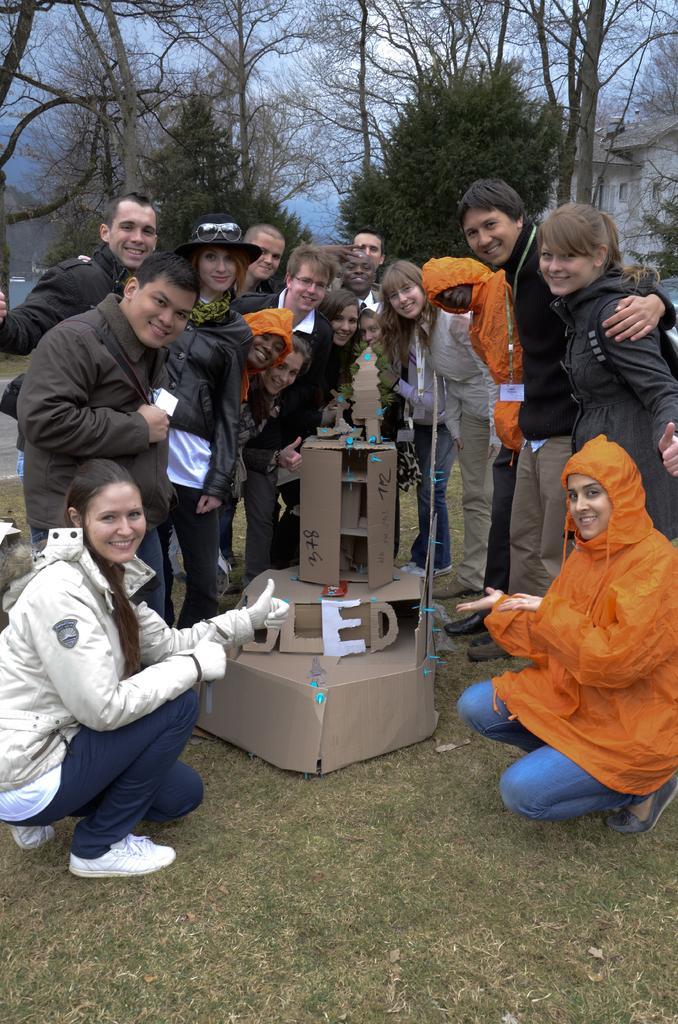Could you give a brief overview of what you see in this image? In this picture there is a model of a building, which is made up of a cardboard and there are people those who are standing around it and there are trees and buildings in the background area of the image. 